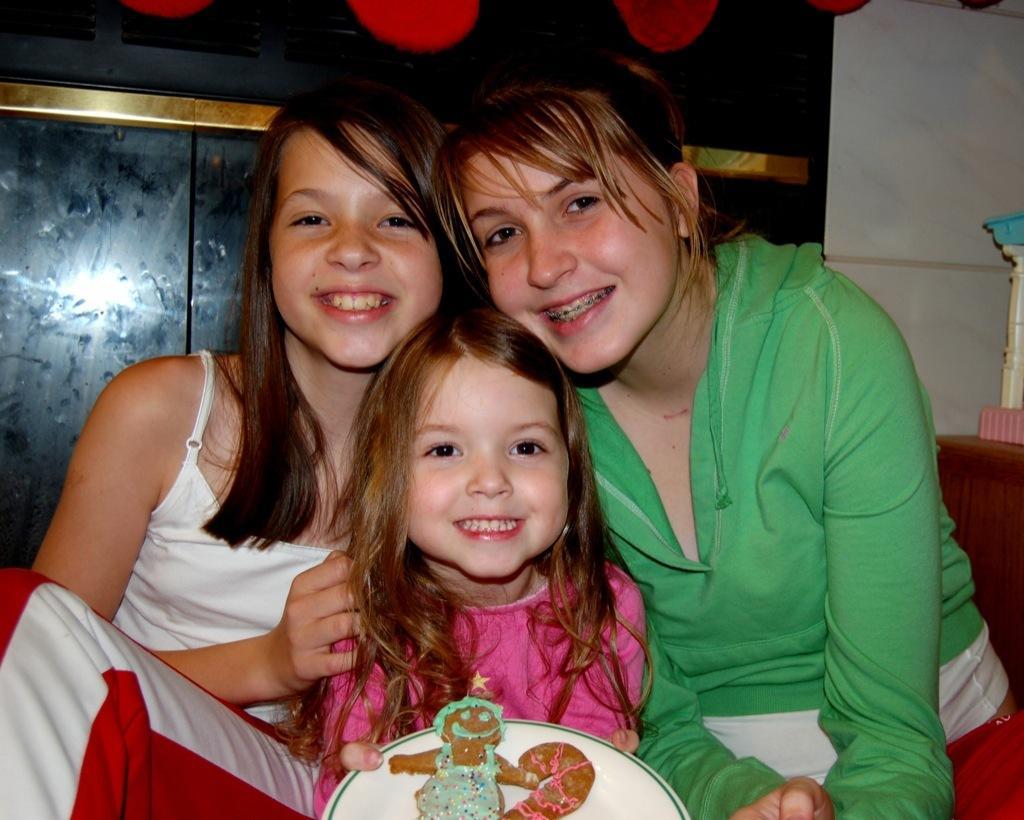Can you describe this image briefly? In the image in the center, we can see three persons are sitting. And they are smiling, which we can see on their faces. And we can see one girl holding plate, in which we can see chocolate. In the background there is a wall, table and a few other objects. 